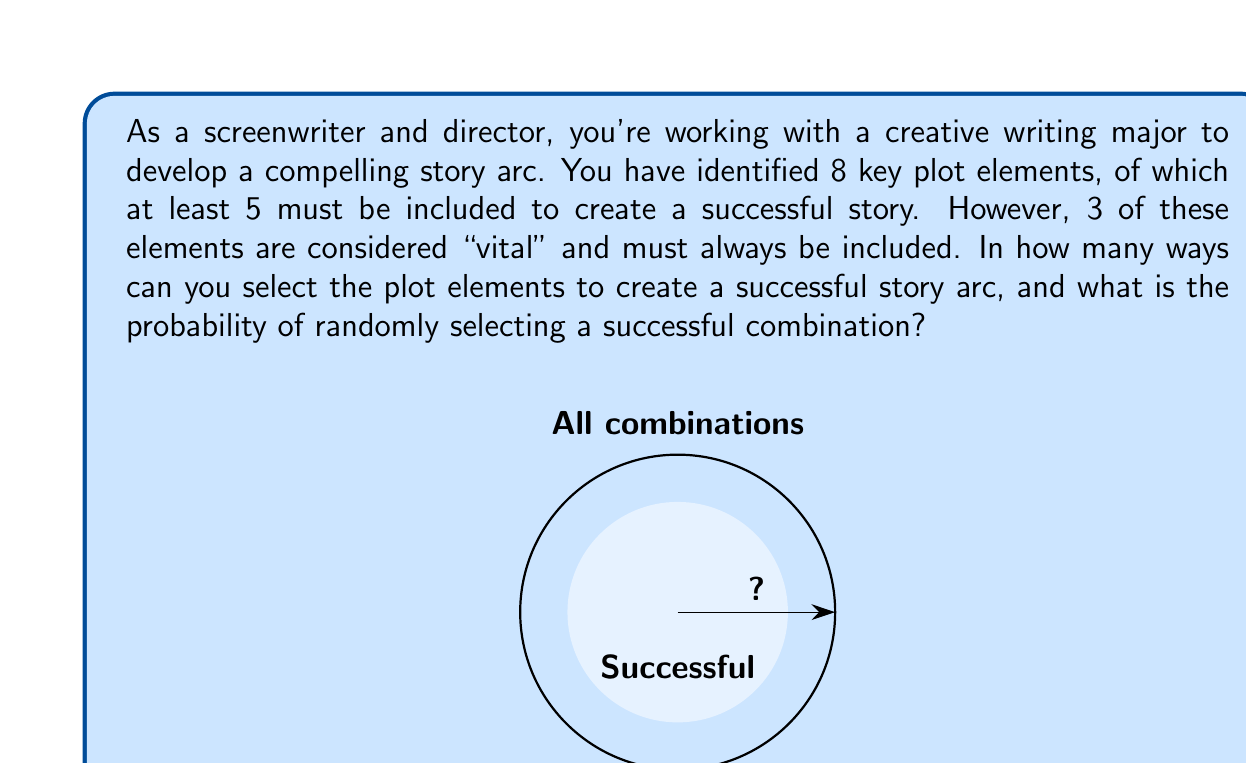Could you help me with this problem? Let's break this down step-by-step:

1) We have 8 total plot elements, of which 3 are vital and must be included.

2) This means we need to choose between 2 and 5 additional elements from the remaining 5 non-vital elements.

3) We can use the combination formula to calculate this:

   $$\binom{5}{2} + \binom{5}{3} + \binom{5}{4} + \binom{5}{5}$$

4) Let's calculate each term:
   $$\binom{5}{2} = 10$$
   $$\binom{5}{3} = 10$$
   $$\binom{5}{4} = 5$$
   $$\binom{5}{5} = 1$$

5) Sum these up: 10 + 10 + 5 + 1 = 26

6) Therefore, there are 26 ways to create a successful story arc.

7) To calculate the probability, we need to know the total number of possible combinations:
   $$\binom{8}{5} + \binom{8}{6} + \binom{8}{7} + \binom{8}{8} = 56 + 28 + 8 + 1 = 93$$

8) The probability is then:
   $$P(\text{successful}) = \frac{26}{93} \approx 0.2796$$
Answer: 26 ways; probability ≈ 0.2796 